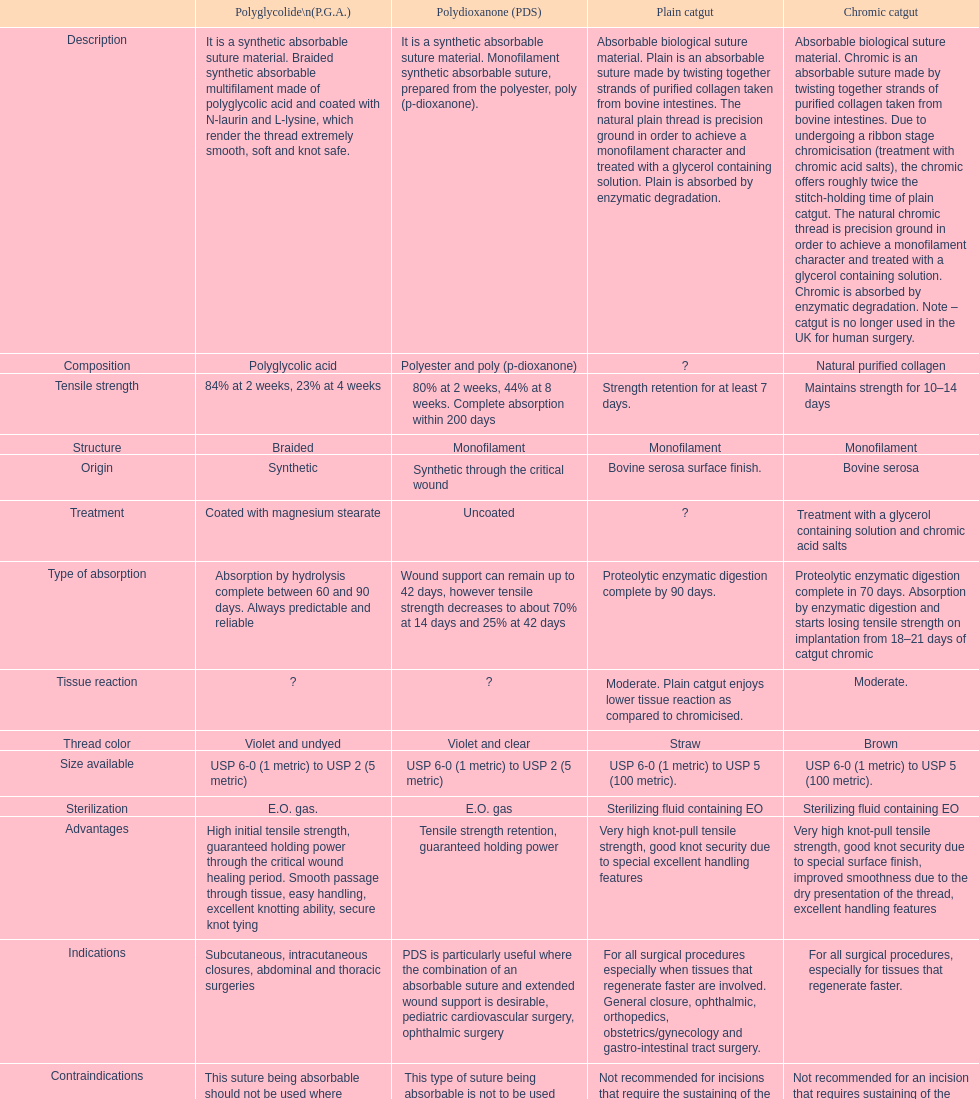Unadorned catgut and chromic catgut both exhibit what form of structure? Monofilament. 